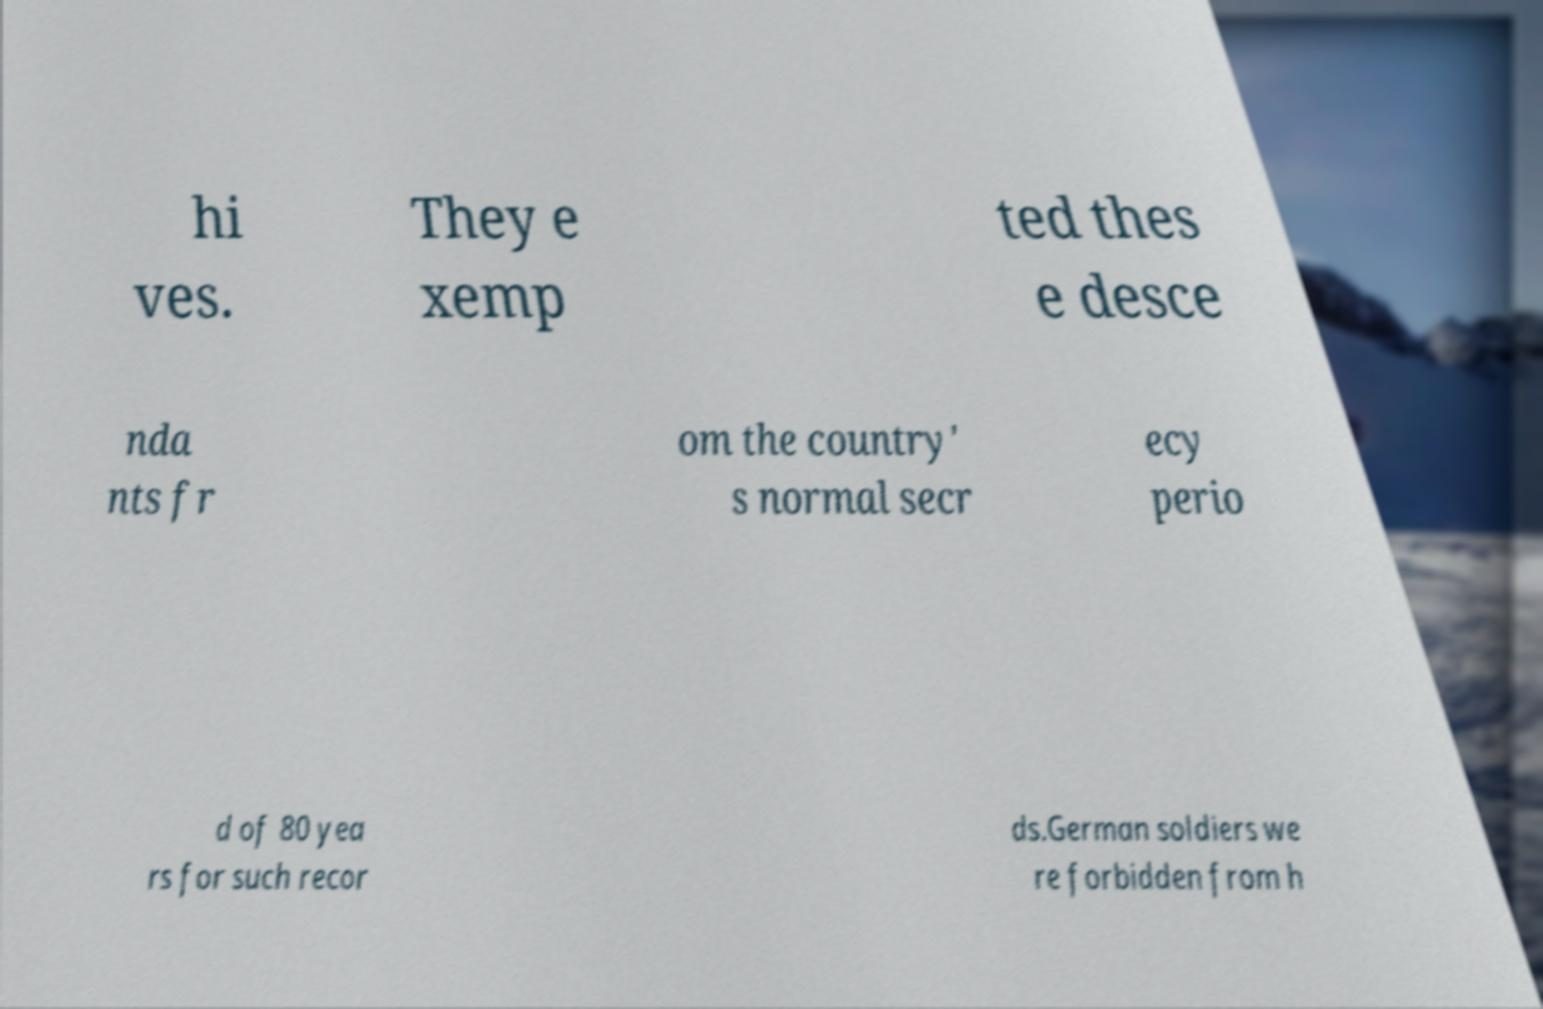Please identify and transcribe the text found in this image. hi ves. They e xemp ted thes e desce nda nts fr om the country' s normal secr ecy perio d of 80 yea rs for such recor ds.German soldiers we re forbidden from h 